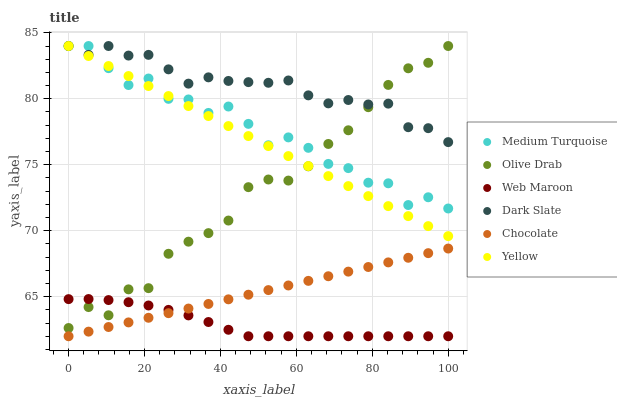Does Web Maroon have the minimum area under the curve?
Answer yes or no. Yes. Does Dark Slate have the maximum area under the curve?
Answer yes or no. Yes. Does Yellow have the minimum area under the curve?
Answer yes or no. No. Does Yellow have the maximum area under the curve?
Answer yes or no. No. Is Chocolate the smoothest?
Answer yes or no. Yes. Is Medium Turquoise the roughest?
Answer yes or no. Yes. Is Yellow the smoothest?
Answer yes or no. No. Is Yellow the roughest?
Answer yes or no. No. Does Web Maroon have the lowest value?
Answer yes or no. Yes. Does Yellow have the lowest value?
Answer yes or no. No. Does Olive Drab have the highest value?
Answer yes or no. Yes. Does Chocolate have the highest value?
Answer yes or no. No. Is Web Maroon less than Yellow?
Answer yes or no. Yes. Is Yellow greater than Chocolate?
Answer yes or no. Yes. Does Yellow intersect Medium Turquoise?
Answer yes or no. Yes. Is Yellow less than Medium Turquoise?
Answer yes or no. No. Is Yellow greater than Medium Turquoise?
Answer yes or no. No. Does Web Maroon intersect Yellow?
Answer yes or no. No. 